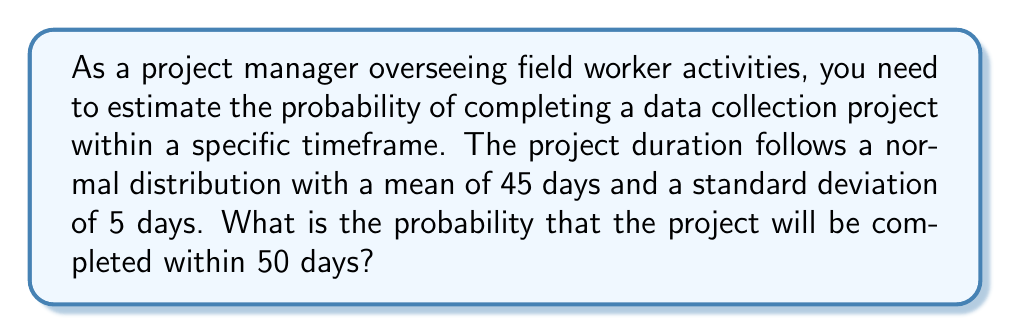Can you answer this question? To solve this problem, we'll use the properties of the normal distribution and the concept of z-scores.

Step 1: Identify the given information
- The project duration follows a normal distribution
- Mean (μ) = 45 days
- Standard deviation (σ) = 5 days
- We want to find P(X ≤ 50), where X is the project duration

Step 2: Calculate the z-score for 50 days
The z-score formula is: $z = \frac{x - \mu}{\sigma}$

Plugging in the values:
$z = \frac{50 - 45}{5} = \frac{5}{5} = 1$

Step 3: Use the standard normal distribution table or calculator
For z = 1, the area under the curve (probability) is approximately 0.8413 or 84.13%

Step 4: Interpret the result
The probability of 0.8413 represents the chance that the project will be completed within 50 days or less.

To visualize this:

[asy]
import graph;
import stats;

size(200,100);

real f(real x) {return exp(-x^2/2)/sqrt(2pi);}

draw(graph(f,-3,3));
fill(graph(f,-3,1),gray(0.7));

label("$\mu=45$",(0,-0.05),S);
label("$50$",(1,-0.05),S);
label("$84.13\%$",(0,0.2),N);

xaxis("Days",Arrow);
yaxis("Probability density",Arrow);
[/asy]
Answer: 0.8413 or 84.13% 